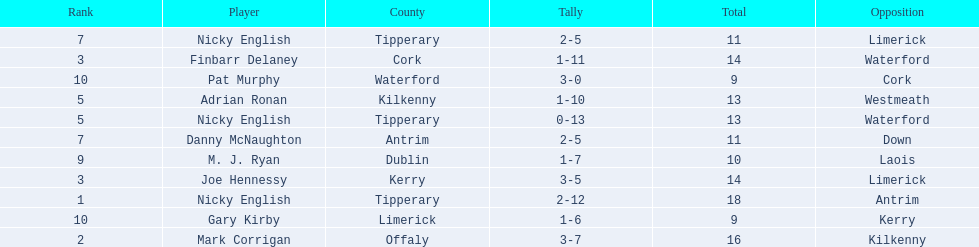Which of the following players were ranked in the bottom 5? Nicky English, Danny McNaughton, M. J. Ryan, Gary Kirby, Pat Murphy. Of these, whose tallies were not 2-5? M. J. Ryan, Gary Kirby, Pat Murphy. From the above three, which one scored more than 9 total points? M. J. Ryan. 